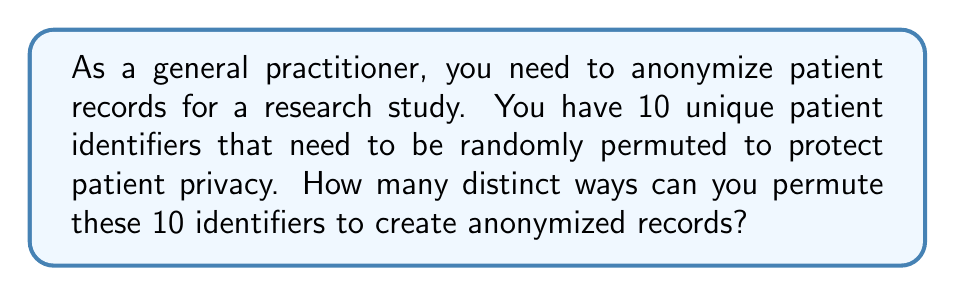Provide a solution to this math problem. To solve this problem, we need to understand the concept of permutations in group theory.

1. In this case, we have 10 distinct patient identifiers, and we want to rearrange all of them.

2. This scenario is a perfect example of a full permutation, where we are arranging all n distinct objects.

3. The number of distinct permutations for n distinct objects is given by the factorial of n, denoted as n!

4. The factorial of a positive integer n is the product of all positive integers less than or equal to n.

   $$n! = n \times (n-1) \times (n-2) \times ... \times 3 \times 2 \times 1$$

5. In our case, n = 10, so we need to calculate 10!

6. Let's compute this step by step:

   $$\begin{align}
   10! &= 10 \times 9 \times 8 \times 7 \times 6 \times 5 \times 4 \times 3 \times 2 \times 1 \\
   &= 3,628,800
   \end{align}$$

Therefore, there are 3,628,800 distinct ways to permute the 10 patient identifiers for anonymization.
Answer: 3,628,800 